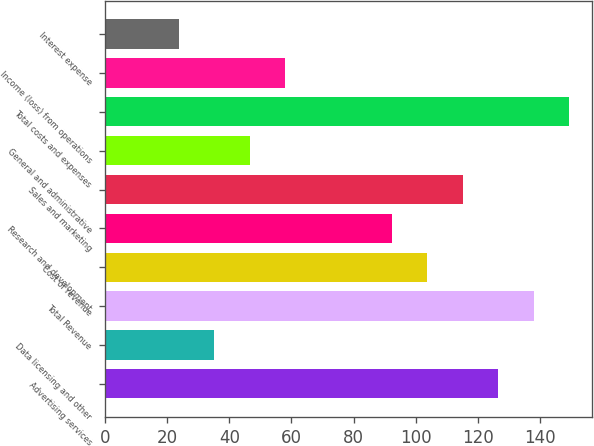Convert chart. <chart><loc_0><loc_0><loc_500><loc_500><bar_chart><fcel>Advertising services<fcel>Data licensing and other<fcel>Total Revenue<fcel>Cost of revenue<fcel>Research and development<fcel>Sales and marketing<fcel>General and administrative<fcel>Total costs and expenses<fcel>Income (loss) from operations<fcel>Interest expense<nl><fcel>126.4<fcel>35.2<fcel>137.8<fcel>103.6<fcel>92.2<fcel>115<fcel>46.6<fcel>149.2<fcel>58<fcel>23.8<nl></chart> 